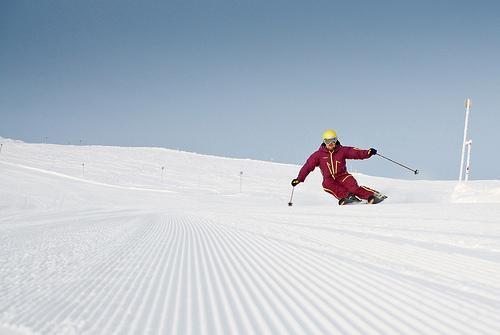How many people are in this picture?
Give a very brief answer. 1. 